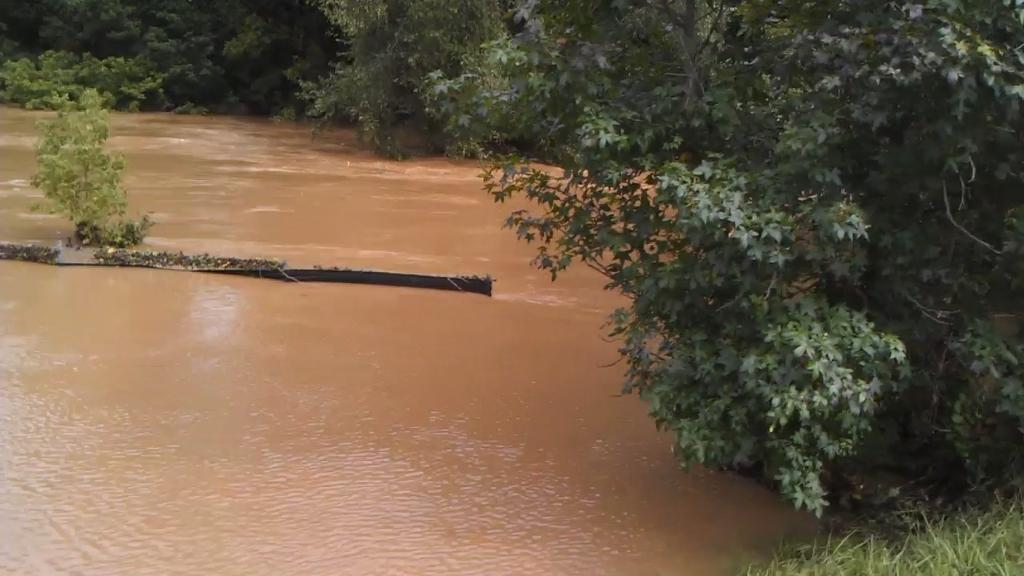What can be seen in the image? There is water visible in the image, and there are trees present as well. Can you describe the water in the image? The water is visible, but its specific characteristics are not mentioned in the facts provided. What type of vegetation is in the image? The trees in the image are a type of vegetation. What type of creature can be seen playing with a cracker in the image? There is no creature or cracker present in the image; it only features water and trees. 